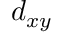Convert formula to latex. <formula><loc_0><loc_0><loc_500><loc_500>d _ { x y }</formula> 